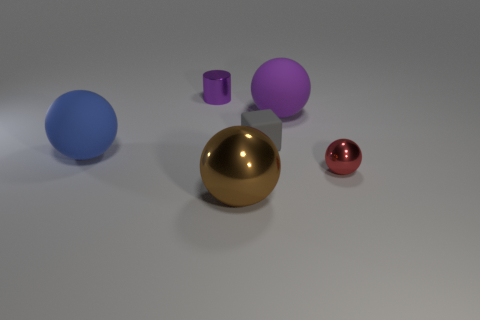Add 3 large shiny cylinders. How many objects exist? 9 Subtract all balls. How many objects are left? 2 Subtract 0 green balls. How many objects are left? 6 Subtract all purple matte spheres. Subtract all brown balls. How many objects are left? 4 Add 4 large purple matte things. How many large purple matte things are left? 5 Add 4 tiny red objects. How many tiny red objects exist? 5 